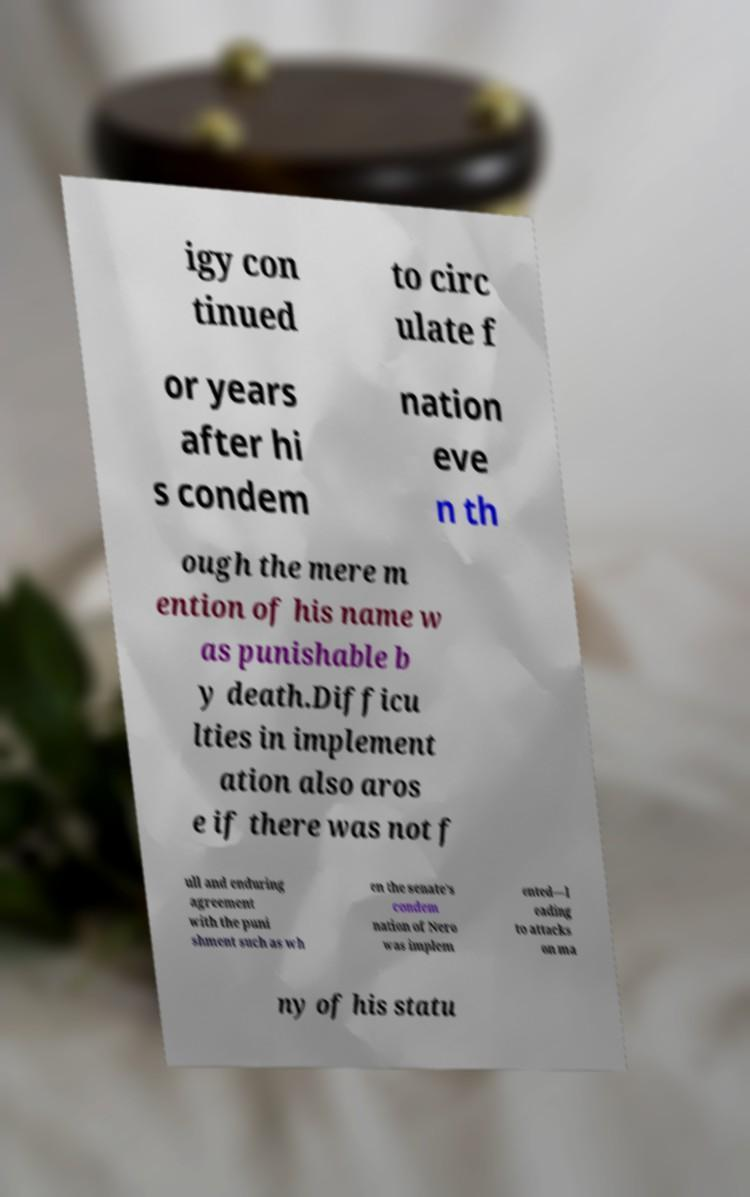Could you assist in decoding the text presented in this image and type it out clearly? igy con tinued to circ ulate f or years after hi s condem nation eve n th ough the mere m ention of his name w as punishable b y death.Difficu lties in implement ation also aros e if there was not f ull and enduring agreement with the puni shment such as wh en the senate's condem nation of Nero was implem ented—l eading to attacks on ma ny of his statu 